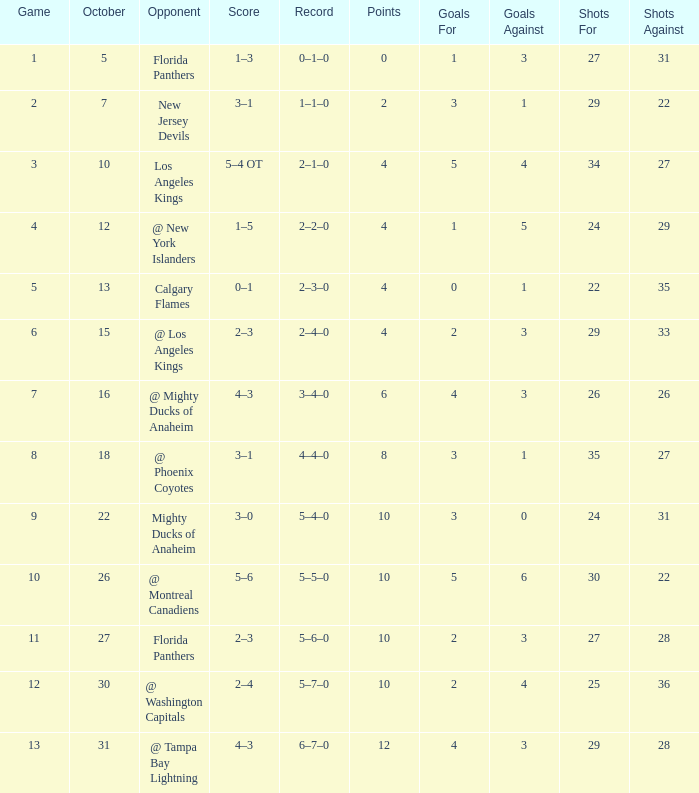What team has a score of 2 3–1. 